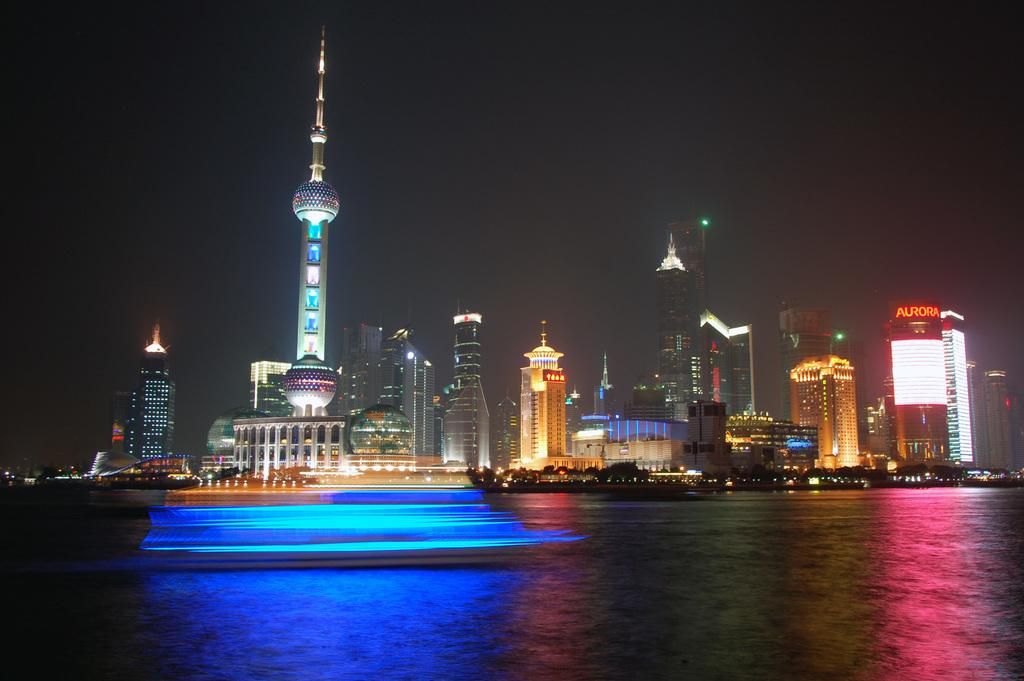What is the primary element present in the image? There is water in the image. What other natural elements can be seen in the image? There are trees in the image. Are there any man-made structures visible? Yes, there are buildings in the image. What part of the natural environment is visible in the image? The sky is visible in the image. How would you describe the lighting in the image? The image appears to be slightly dark. What type of toys can be seen on the sofa in the image? There is no sofa or toys present in the image. What kind of competition is taking place in the image? There is no competition present in the image. 